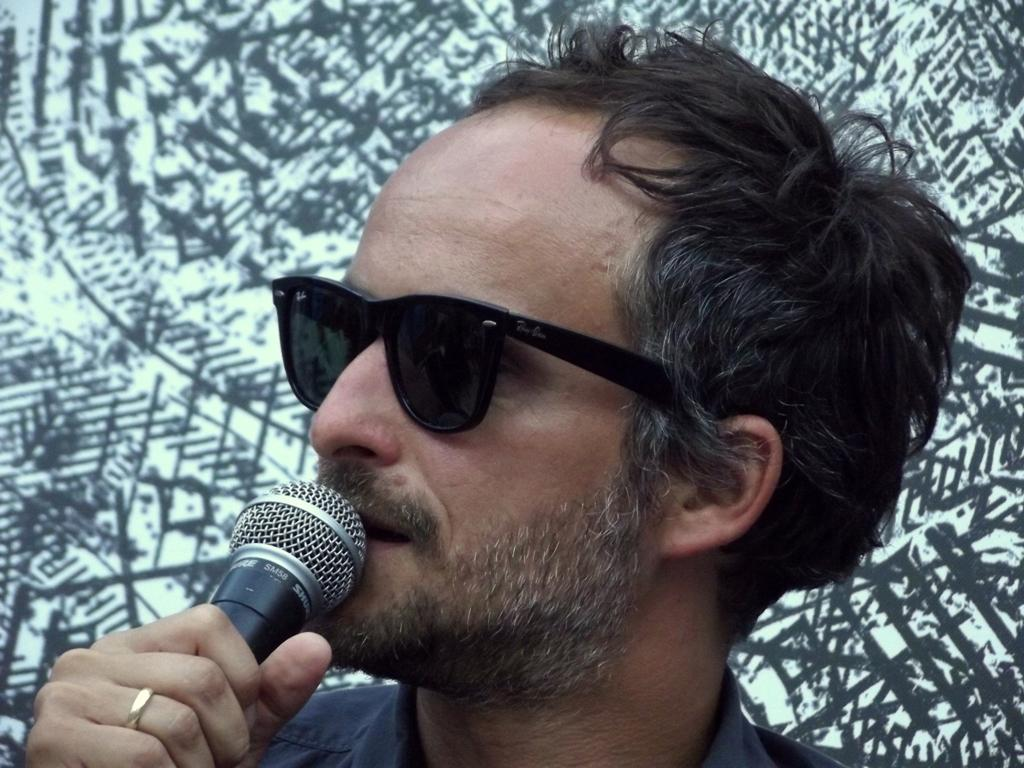Who or what is the main subject in the image? There is a person in the image. What is the person wearing? The person is wearing goggles. What object is the person holding in his hand? The person is holding a microphone in his hand. What type of sheet is being used to cover the person's mouth in the image? There is no sheet present in the image, and the person's mouth is not covered. 